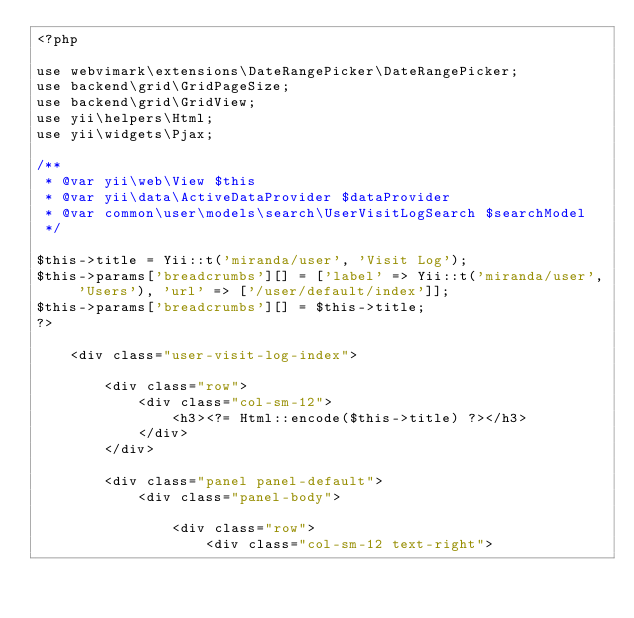Convert code to text. <code><loc_0><loc_0><loc_500><loc_500><_PHP_><?php

use webvimark\extensions\DateRangePicker\DateRangePicker;
use backend\grid\GridPageSize;
use backend\grid\GridView;
use yii\helpers\Html;
use yii\widgets\Pjax;

/**
 * @var yii\web\View $this
 * @var yii\data\ActiveDataProvider $dataProvider
 * @var common\user\models\search\UserVisitLogSearch $searchModel
 */

$this->title = Yii::t('miranda/user', 'Visit Log');
$this->params['breadcrumbs'][] = ['label' => Yii::t('miranda/user', 'Users'), 'url' => ['/user/default/index']];
$this->params['breadcrumbs'][] = $this->title;
?>

    <div class="user-visit-log-index">

        <div class="row">
            <div class="col-sm-12">
                <h3><?= Html::encode($this->title) ?></h3>
            </div>
        </div>

        <div class="panel panel-default">
            <div class="panel-body">

                <div class="row">
                    <div class="col-sm-12 text-right"></code> 